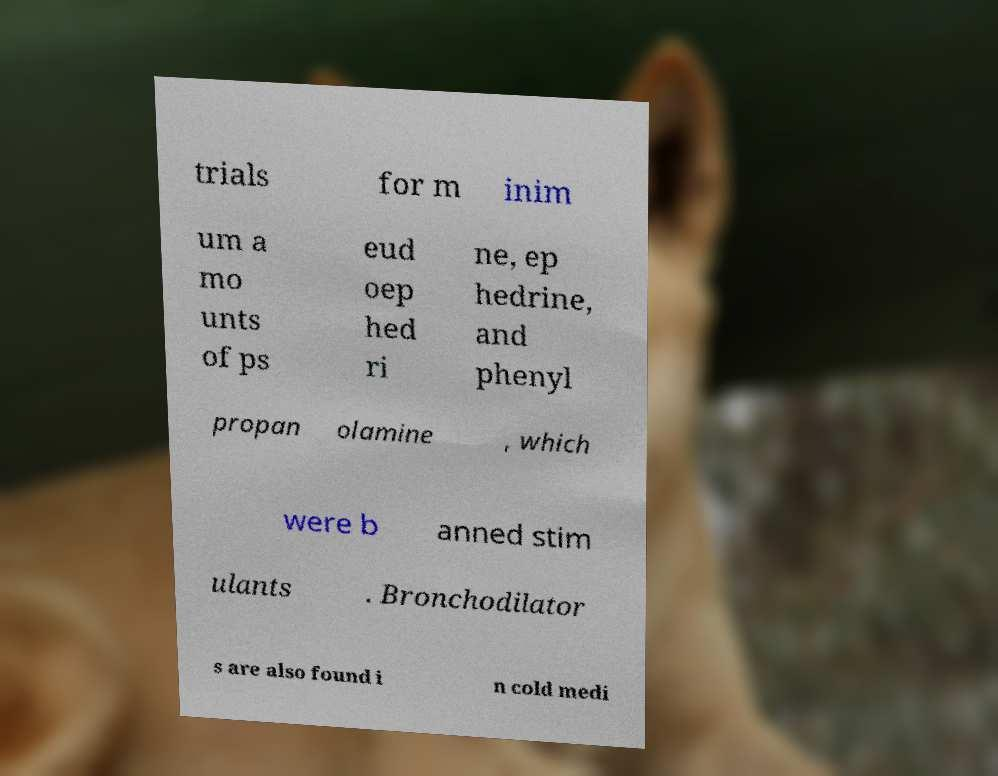Could you extract and type out the text from this image? trials for m inim um a mo unts of ps eud oep hed ri ne, ep hedrine, and phenyl propan olamine , which were b anned stim ulants . Bronchodilator s are also found i n cold medi 